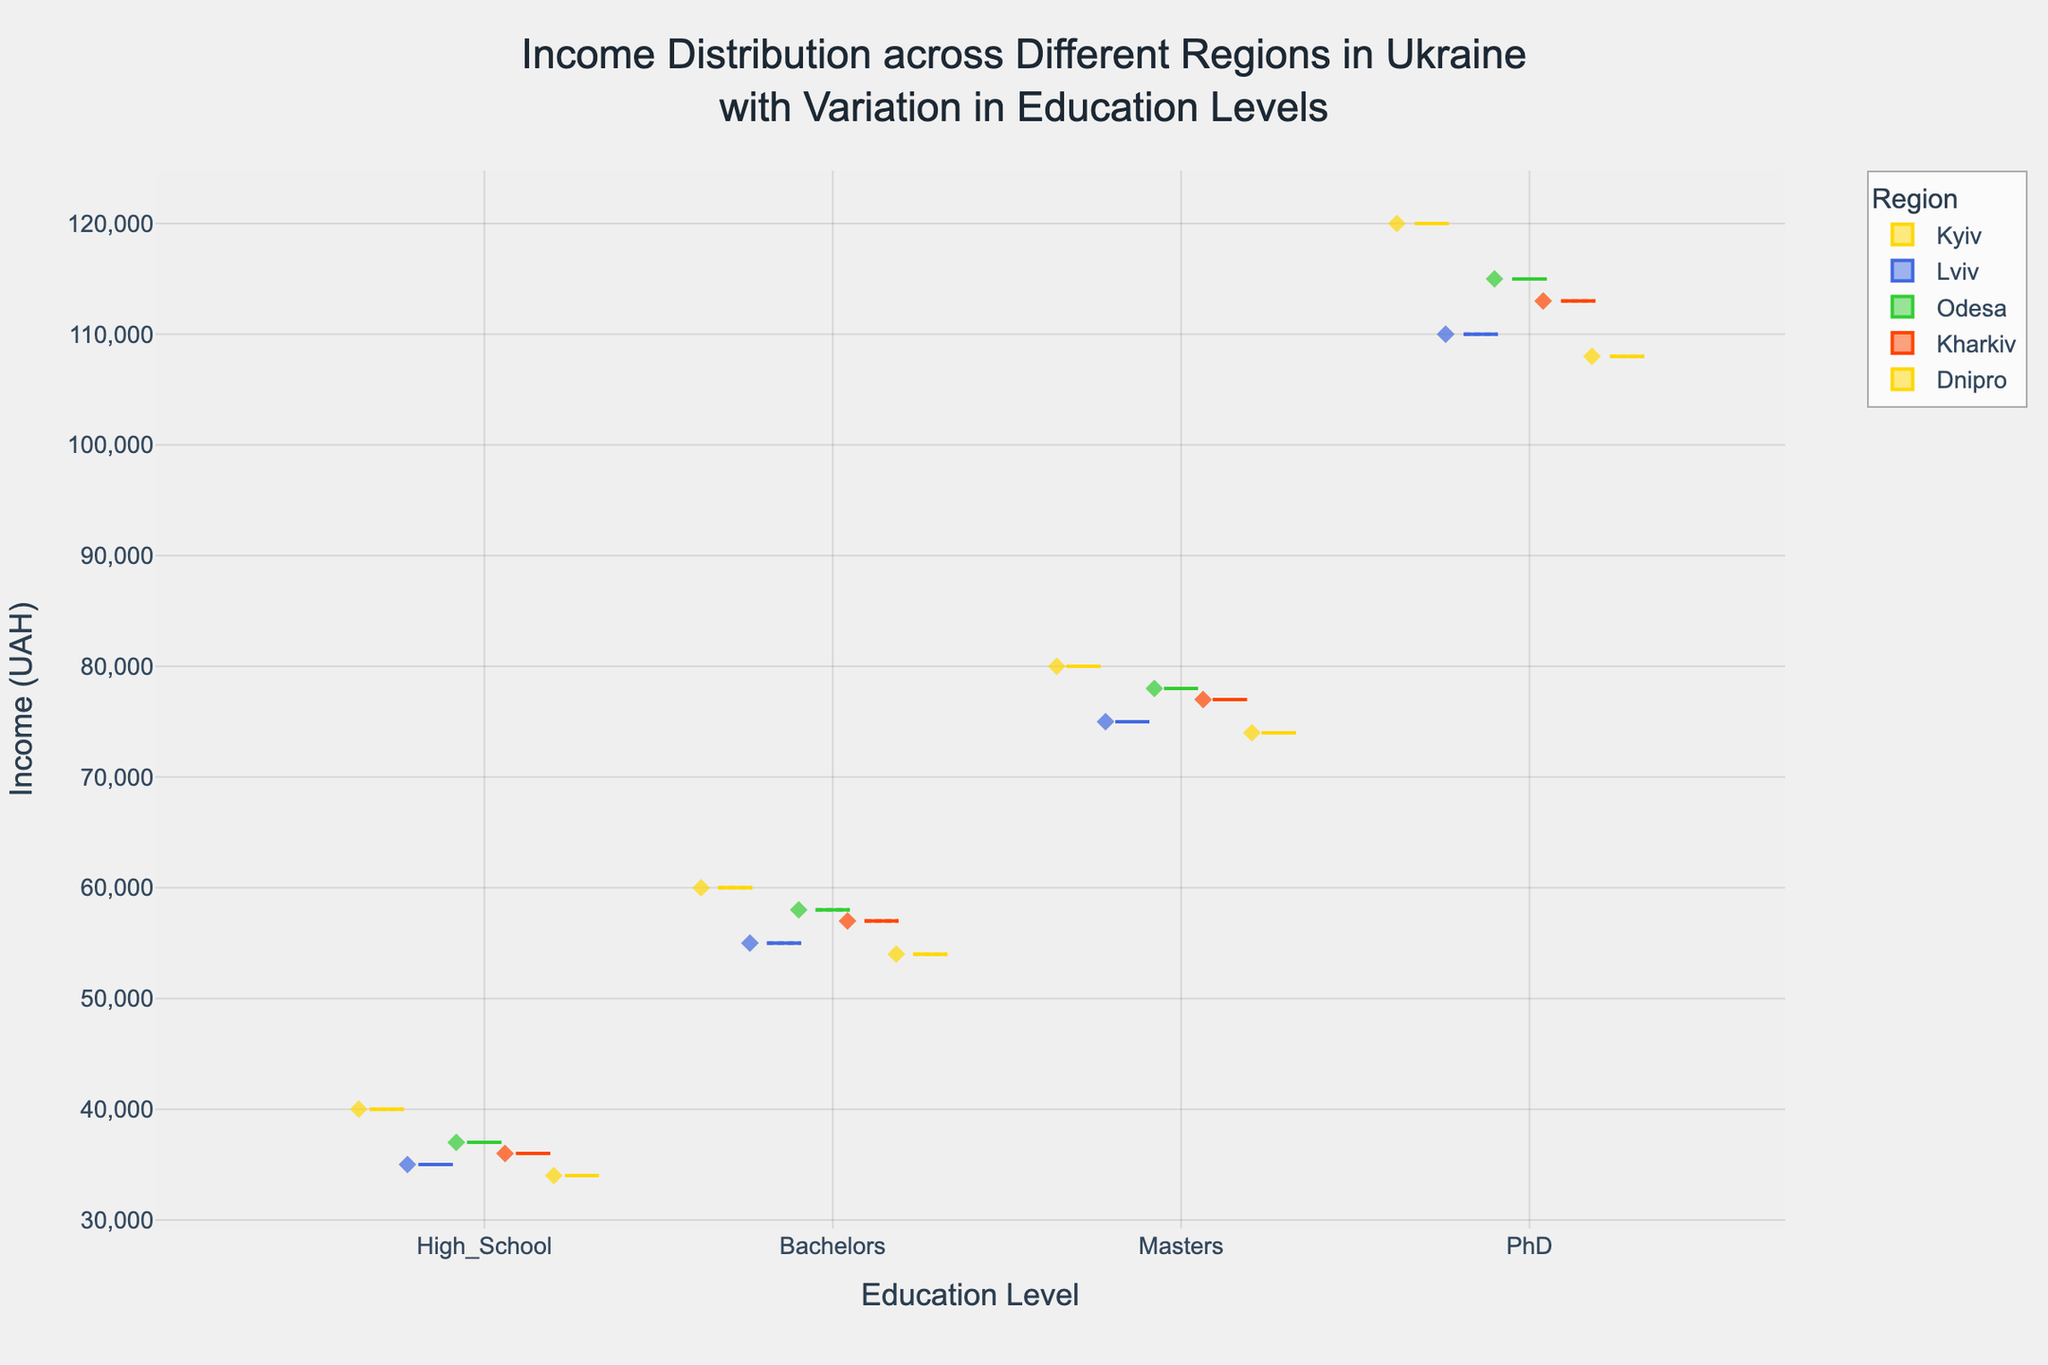What is the title of the plot? The title can be found at the top of the plot, indicating the focus of the visualization.
Answer: Income Distribution across Different Regions in Ukraine with Variation in Education Levels Which education level shows the highest income in Kyiv? By examining the box representing Kyiv, we can see that the highest income is for the PhD education level, indicated by the box plot with the highest median and outliers.
Answer: PhD What is the median income for PhD holders in Lviv? The median is represented by the line inside the box plot for the PhD level in the Lviv region.
Answer: 110,000 UAH Compare the median income of Bachelors in Kyiv and Odesa. Which region has a higher median income? By comparing the median lines in the box plots for Bachelors in Kyiv and Odesa, we can see that Kyiv has a higher median income.
Answer: Kyiv How does the range of income for Masters degree holders in Kharkiv compare to that in Dnipro? The range is determined by the distance between the lower and upper whiskers. The range for Kharkiv is between approximately 77,000 and 36,000, while for Dnipro it is between approximately 74,000 and 34,000.
Answer: Kharkiv has a wider range Which region shows the greatest variability in income for High School education level? Variability is indicated by the spread of the box and whiskers. For the High School education level, Kyiv has the widest spread, indicating the greatest variability.
Answer: Kyiv What is the trend in median income as education levels increase in Odesa? The median income increases progressively with each higher level of education, showing a trend of higher education leading to higher incomes.
Answer: Increases Identify the region with the smallest interquartile range (IQR) for Masters level income. The IQR is the box's width. By comparing the boxes for the Masters level across all regions, Dnipro has the smallest IQR.
Answer: Dnipro Which education level has the closest median incomes across all regions? By examining the medians across all regions for each education level, the High School level has medians that are closest in value.
Answer: High School 